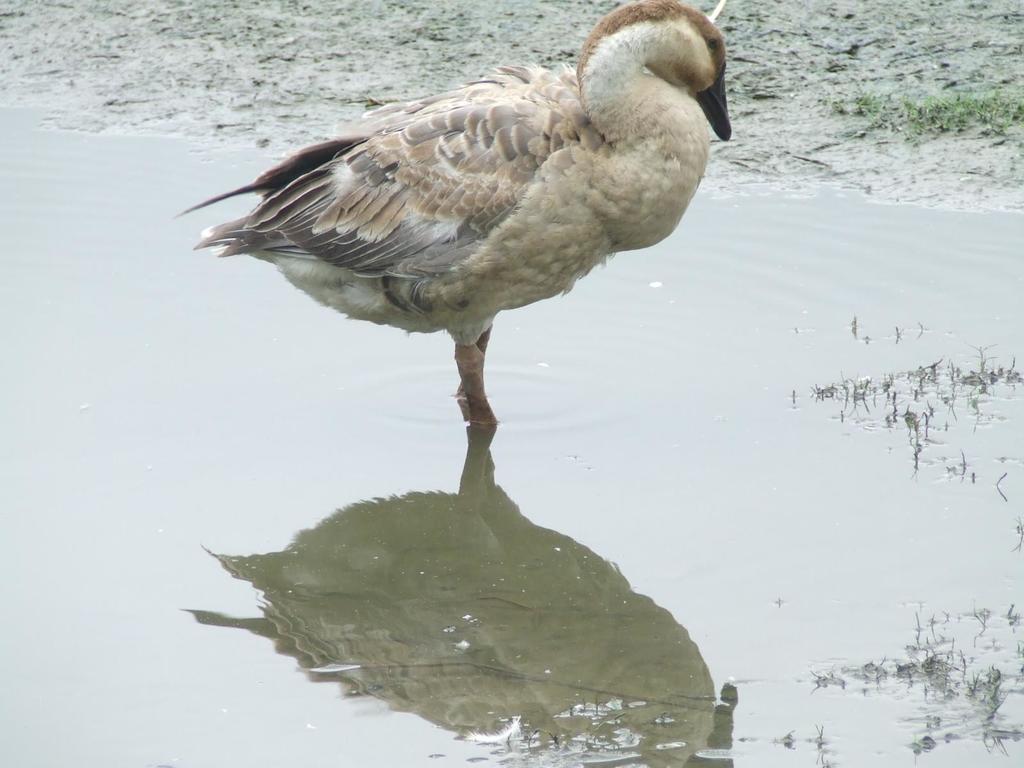Please provide a concise description of this image. In this image I can see the bird in the water and the bird is in cream and brown color. In the background the grass is in green color. 